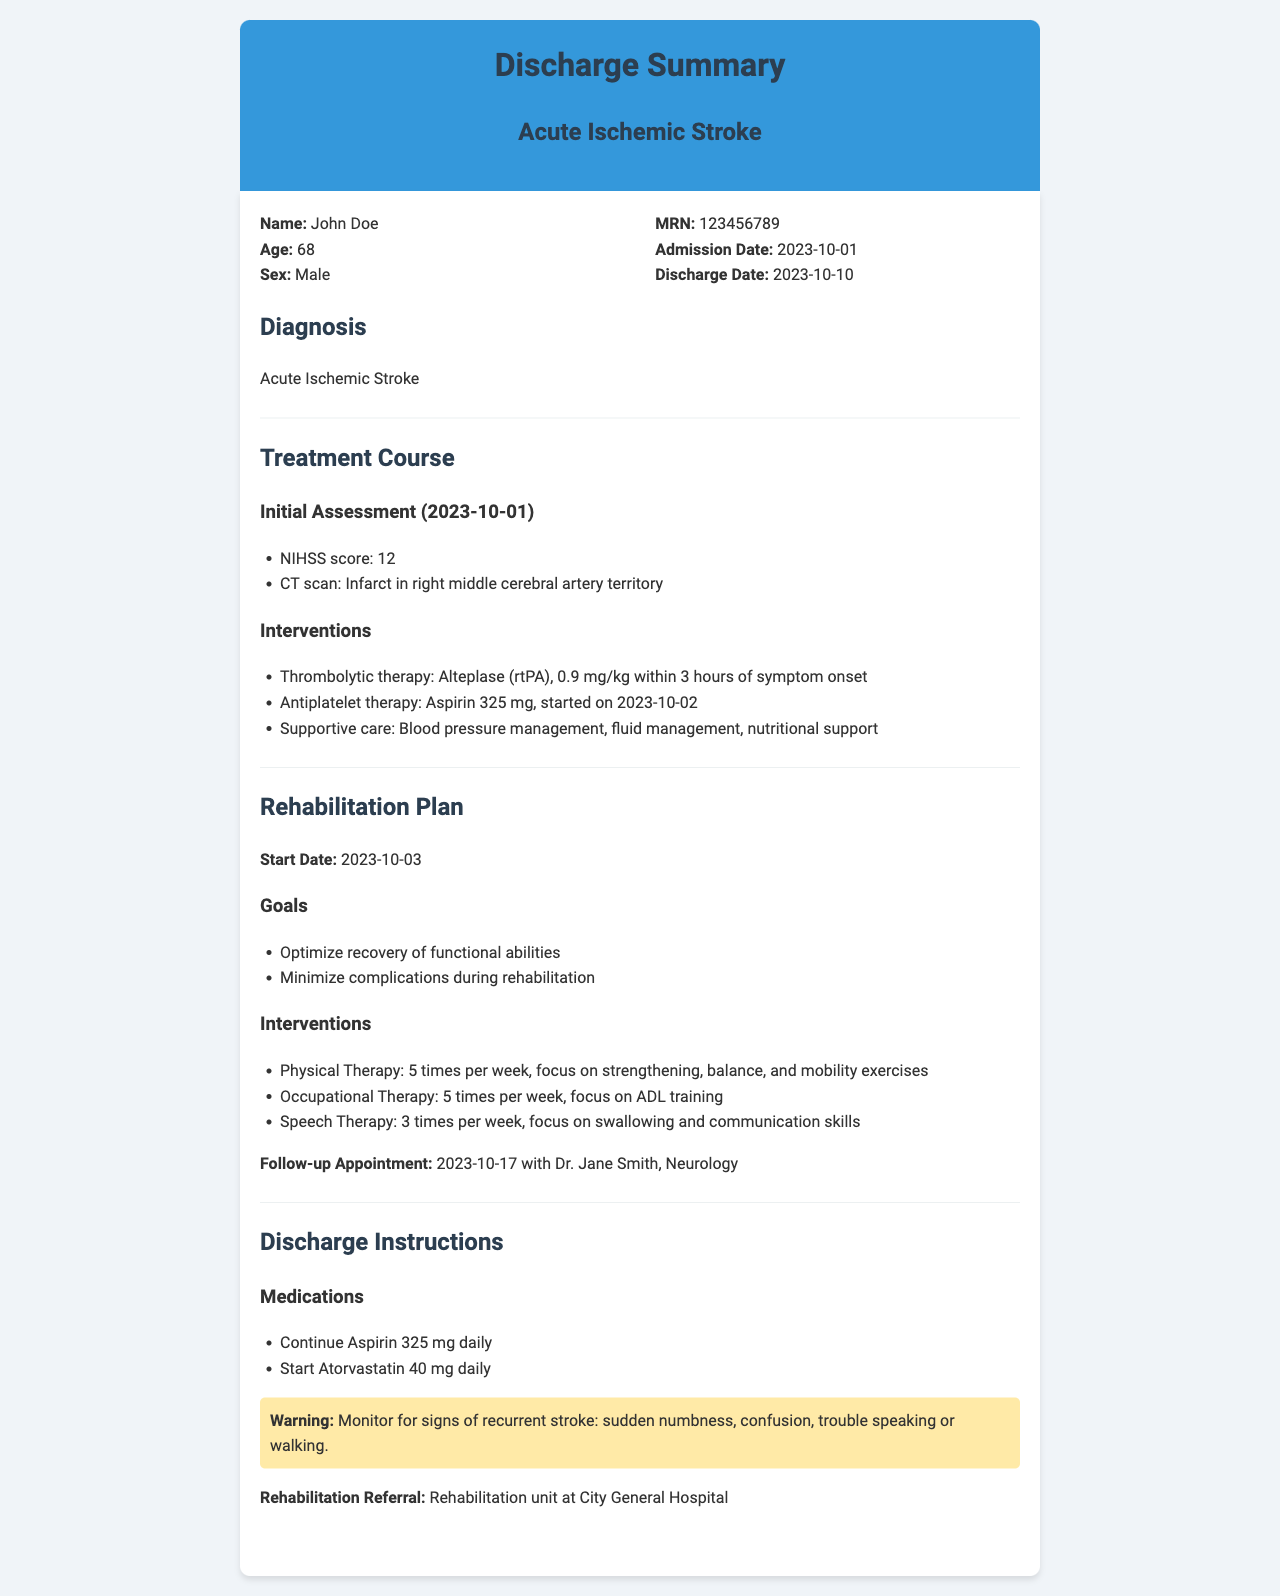What is the patient's name? The patient's name is mentioned in the patient-info section.
Answer: John Doe What was the NIHSS score on initial assessment? The NIHSS score is listed under the initial assessment date.
Answer: 12 What medication was started on 2023-10-02? The document specifies the medication that began on this date under interventions.
Answer: Aspirin 325 mg How often is physical therapy scheduled? The frequency of physical therapy is noted in the rehabilitation plan section.
Answer: 5 times per week What is the follow-up appointment date? The follow-up appointment date is detailed in the rehabilitation plan section.
Answer: 2023-10-17 Which artery was involved in the infarct? The document states the artery affected in the CT scan results.
Answer: Right middle cerebral artery What is the main goal of the rehabilitation plan? The main goal is outlined at the beginning of the rehabilitation plan section.
Answer: Optimize recovery of functional abilities What new medication is prescribed at discharge? The document lists the new medication under the discharge instructions.
Answer: Atorvastatin 40 mg daily What warning is provided in the discharge instructions? The warning is included in a highlighted section under discharge instructions.
Answer: Monitor for signs of recurrent stroke: sudden numbness, confusion, trouble speaking or walking 